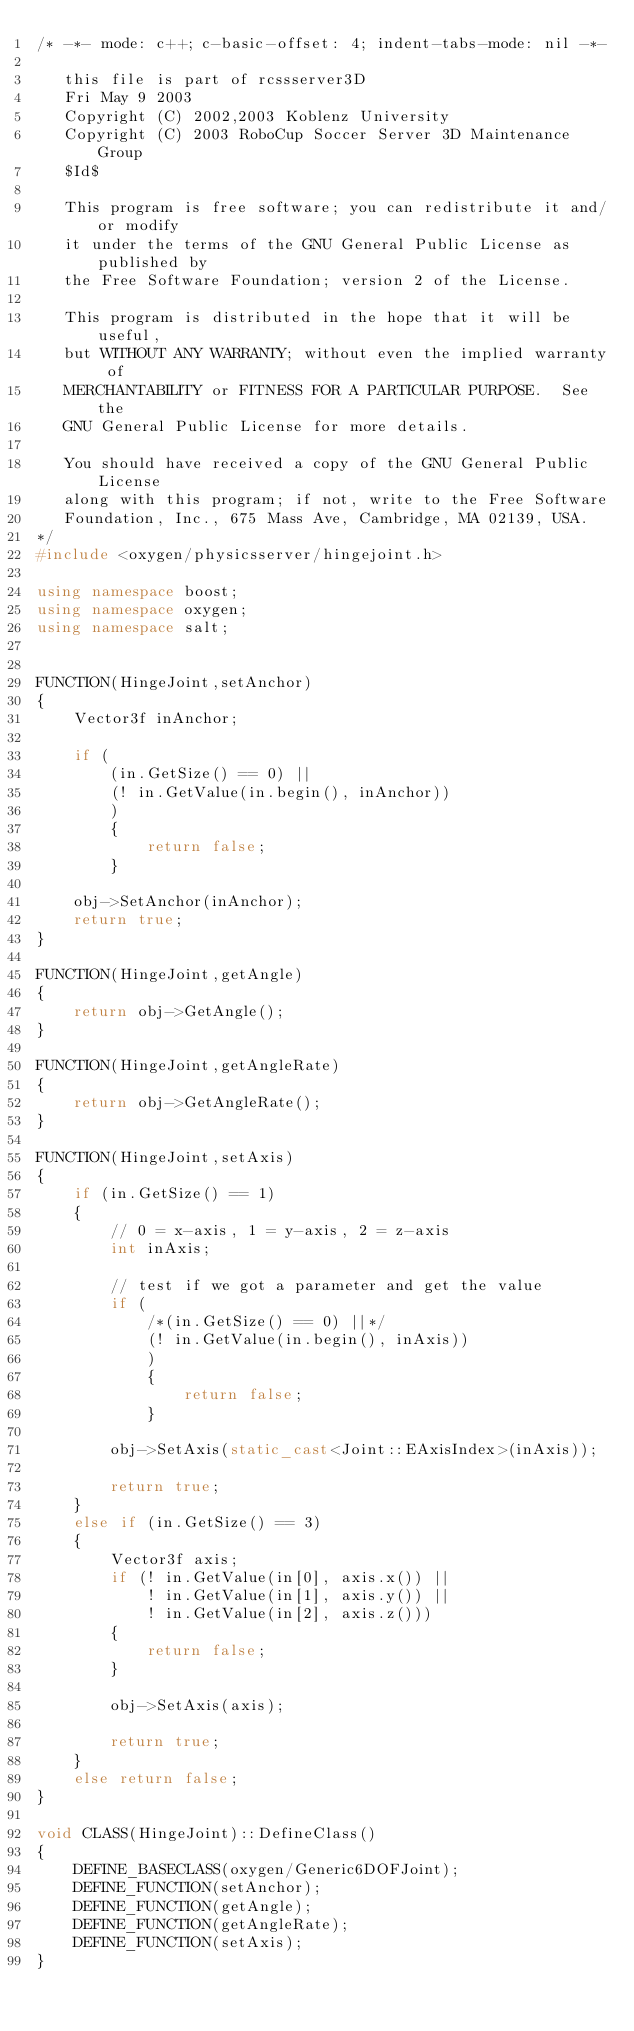<code> <loc_0><loc_0><loc_500><loc_500><_C++_>/* -*- mode: c++; c-basic-offset: 4; indent-tabs-mode: nil -*-

   this file is part of rcssserver3D
   Fri May 9 2003
   Copyright (C) 2002,2003 Koblenz University
   Copyright (C) 2003 RoboCup Soccer Server 3D Maintenance Group
   $Id$

   This program is free software; you can redistribute it and/or modify
   it under the terms of the GNU General Public License as published by
   the Free Software Foundation; version 2 of the License.

   This program is distributed in the hope that it will be useful,
   but WITHOUT ANY WARRANTY; without even the implied warranty of
   MERCHANTABILITY or FITNESS FOR A PARTICULAR PURPOSE.  See the
   GNU General Public License for more details.

   You should have received a copy of the GNU General Public License
   along with this program; if not, write to the Free Software
   Foundation, Inc., 675 Mass Ave, Cambridge, MA 02139, USA.
*/
#include <oxygen/physicsserver/hingejoint.h>

using namespace boost;
using namespace oxygen;
using namespace salt;


FUNCTION(HingeJoint,setAnchor)
{
    Vector3f inAnchor;

    if (
        (in.GetSize() == 0) ||
        (! in.GetValue(in.begin(), inAnchor))
        )
        {
            return false;
        }

    obj->SetAnchor(inAnchor);
    return true;
}

FUNCTION(HingeJoint,getAngle)
{
    return obj->GetAngle();
}

FUNCTION(HingeJoint,getAngleRate)
{
    return obj->GetAngleRate();
}

FUNCTION(HingeJoint,setAxis)
{
    if (in.GetSize() == 1)
    {
        // 0 = x-axis, 1 = y-axis, 2 = z-axis
        int inAxis;

        // test if we got a parameter and get the value
        if (
            /*(in.GetSize() == 0) ||*/
            (! in.GetValue(in.begin(), inAxis))
            )
            {
                return false;
            }

        obj->SetAxis(static_cast<Joint::EAxisIndex>(inAxis));
    	
        return true;
    }
    else if (in.GetSize() == 3)
    {
        Vector3f axis;
        if (! in.GetValue(in[0], axis.x()) ||
            ! in.GetValue(in[1], axis.y()) ||
            ! in.GetValue(in[2], axis.z()))
        {
            return false;
        }
        
        obj->SetAxis(axis);      
 
        return true;
    }
    else return false;
}

void CLASS(HingeJoint)::DefineClass()
{
    DEFINE_BASECLASS(oxygen/Generic6DOFJoint);
    DEFINE_FUNCTION(setAnchor);
    DEFINE_FUNCTION(getAngle);
    DEFINE_FUNCTION(getAngleRate);
    DEFINE_FUNCTION(setAxis);
}
</code> 